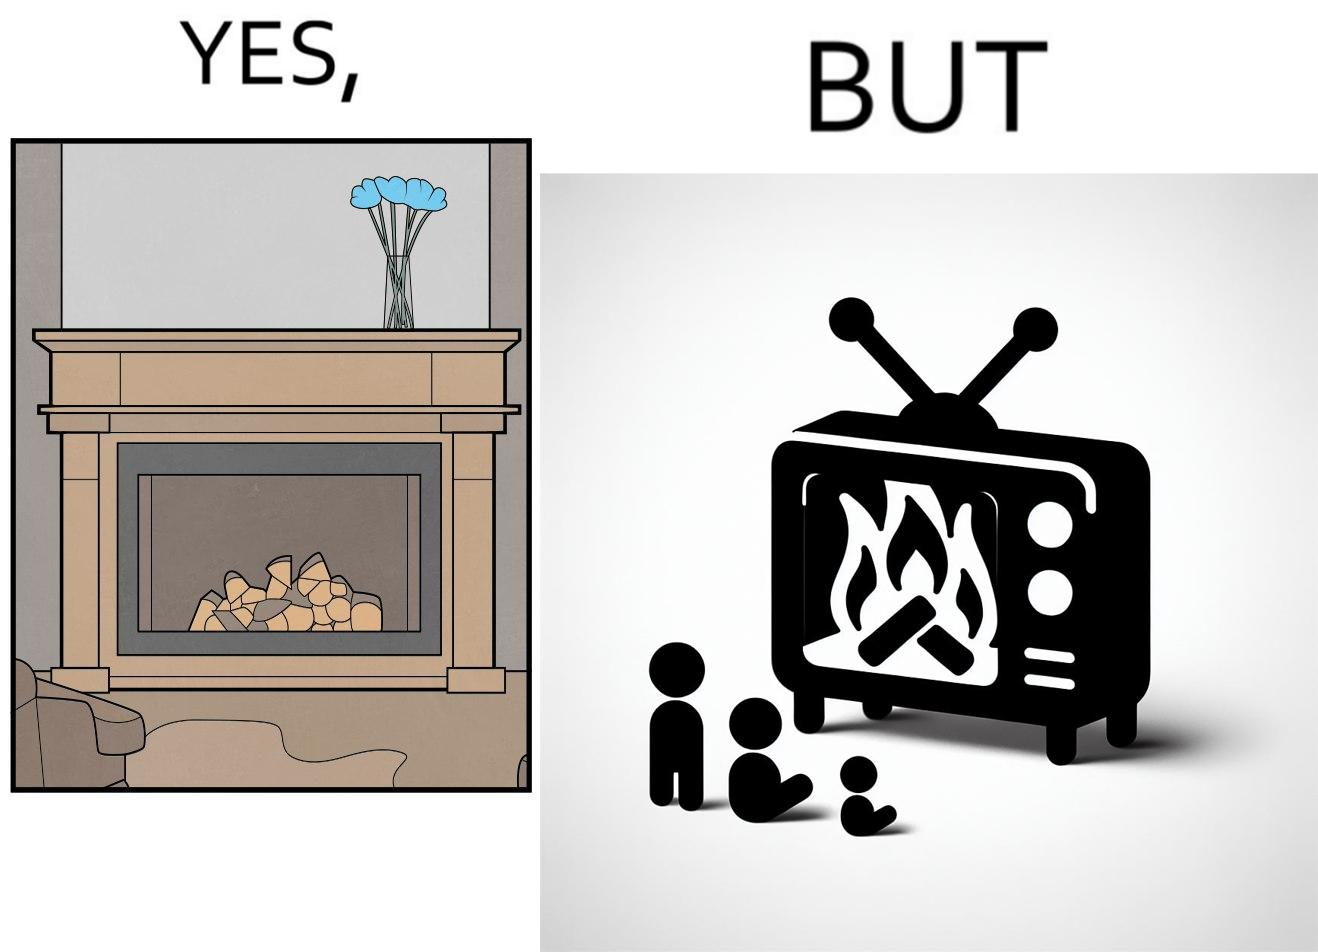What does this image depict? The images are funny since they show how even though real fireplaces exist, people choose to be lazy and watch fireplaces on television because they dont want the inconveniences of cleaning up, etc. afterwards 